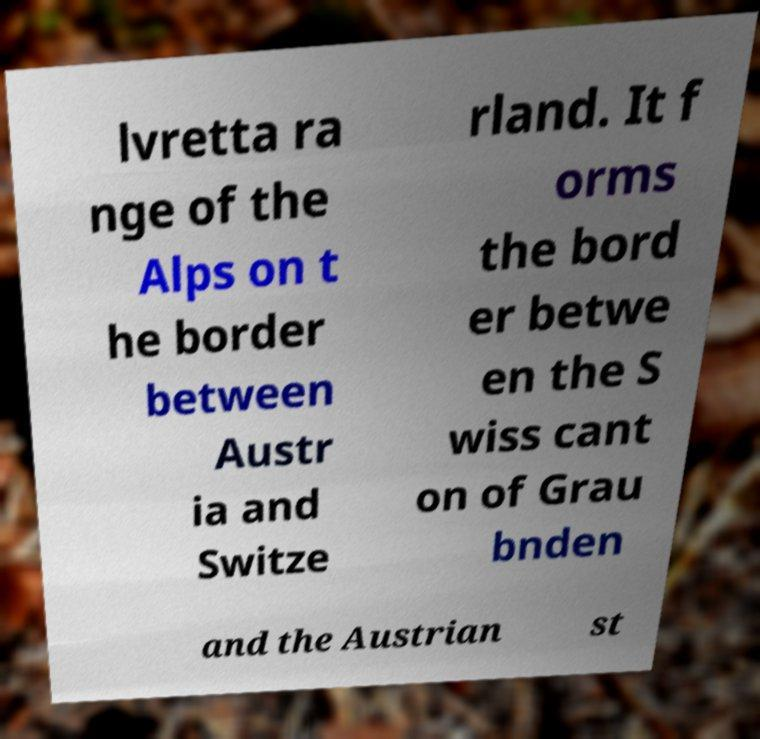Can you accurately transcribe the text from the provided image for me? lvretta ra nge of the Alps on t he border between Austr ia and Switze rland. It f orms the bord er betwe en the S wiss cant on of Grau bnden and the Austrian st 